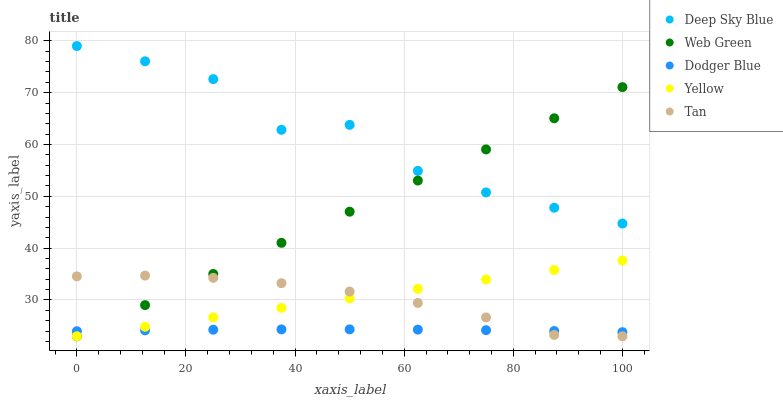Does Dodger Blue have the minimum area under the curve?
Answer yes or no. Yes. Does Deep Sky Blue have the maximum area under the curve?
Answer yes or no. Yes. Does Yellow have the minimum area under the curve?
Answer yes or no. No. Does Yellow have the maximum area under the curve?
Answer yes or no. No. Is Yellow the smoothest?
Answer yes or no. Yes. Is Deep Sky Blue the roughest?
Answer yes or no. Yes. Is Dodger Blue the smoothest?
Answer yes or no. No. Is Dodger Blue the roughest?
Answer yes or no. No. Does Tan have the lowest value?
Answer yes or no. Yes. Does Dodger Blue have the lowest value?
Answer yes or no. No. Does Deep Sky Blue have the highest value?
Answer yes or no. Yes. Does Yellow have the highest value?
Answer yes or no. No. Is Yellow less than Deep Sky Blue?
Answer yes or no. Yes. Is Deep Sky Blue greater than Dodger Blue?
Answer yes or no. Yes. Does Dodger Blue intersect Web Green?
Answer yes or no. Yes. Is Dodger Blue less than Web Green?
Answer yes or no. No. Is Dodger Blue greater than Web Green?
Answer yes or no. No. Does Yellow intersect Deep Sky Blue?
Answer yes or no. No. 